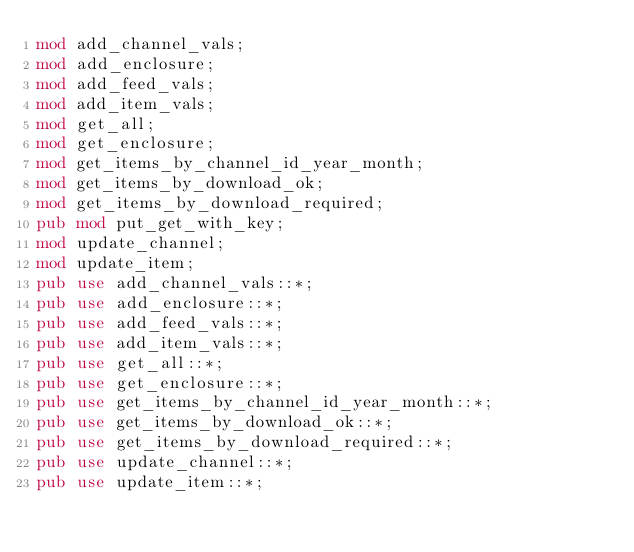<code> <loc_0><loc_0><loc_500><loc_500><_Rust_>mod add_channel_vals;
mod add_enclosure;
mod add_feed_vals;
mod add_item_vals;
mod get_all;
mod get_enclosure;
mod get_items_by_channel_id_year_month;
mod get_items_by_download_ok;
mod get_items_by_download_required;
pub mod put_get_with_key;
mod update_channel;
mod update_item;
pub use add_channel_vals::*;
pub use add_enclosure::*;
pub use add_feed_vals::*;
pub use add_item_vals::*;
pub use get_all::*;
pub use get_enclosure::*;
pub use get_items_by_channel_id_year_month::*;
pub use get_items_by_download_ok::*;
pub use get_items_by_download_required::*;
pub use update_channel::*;
pub use update_item::*;
</code> 